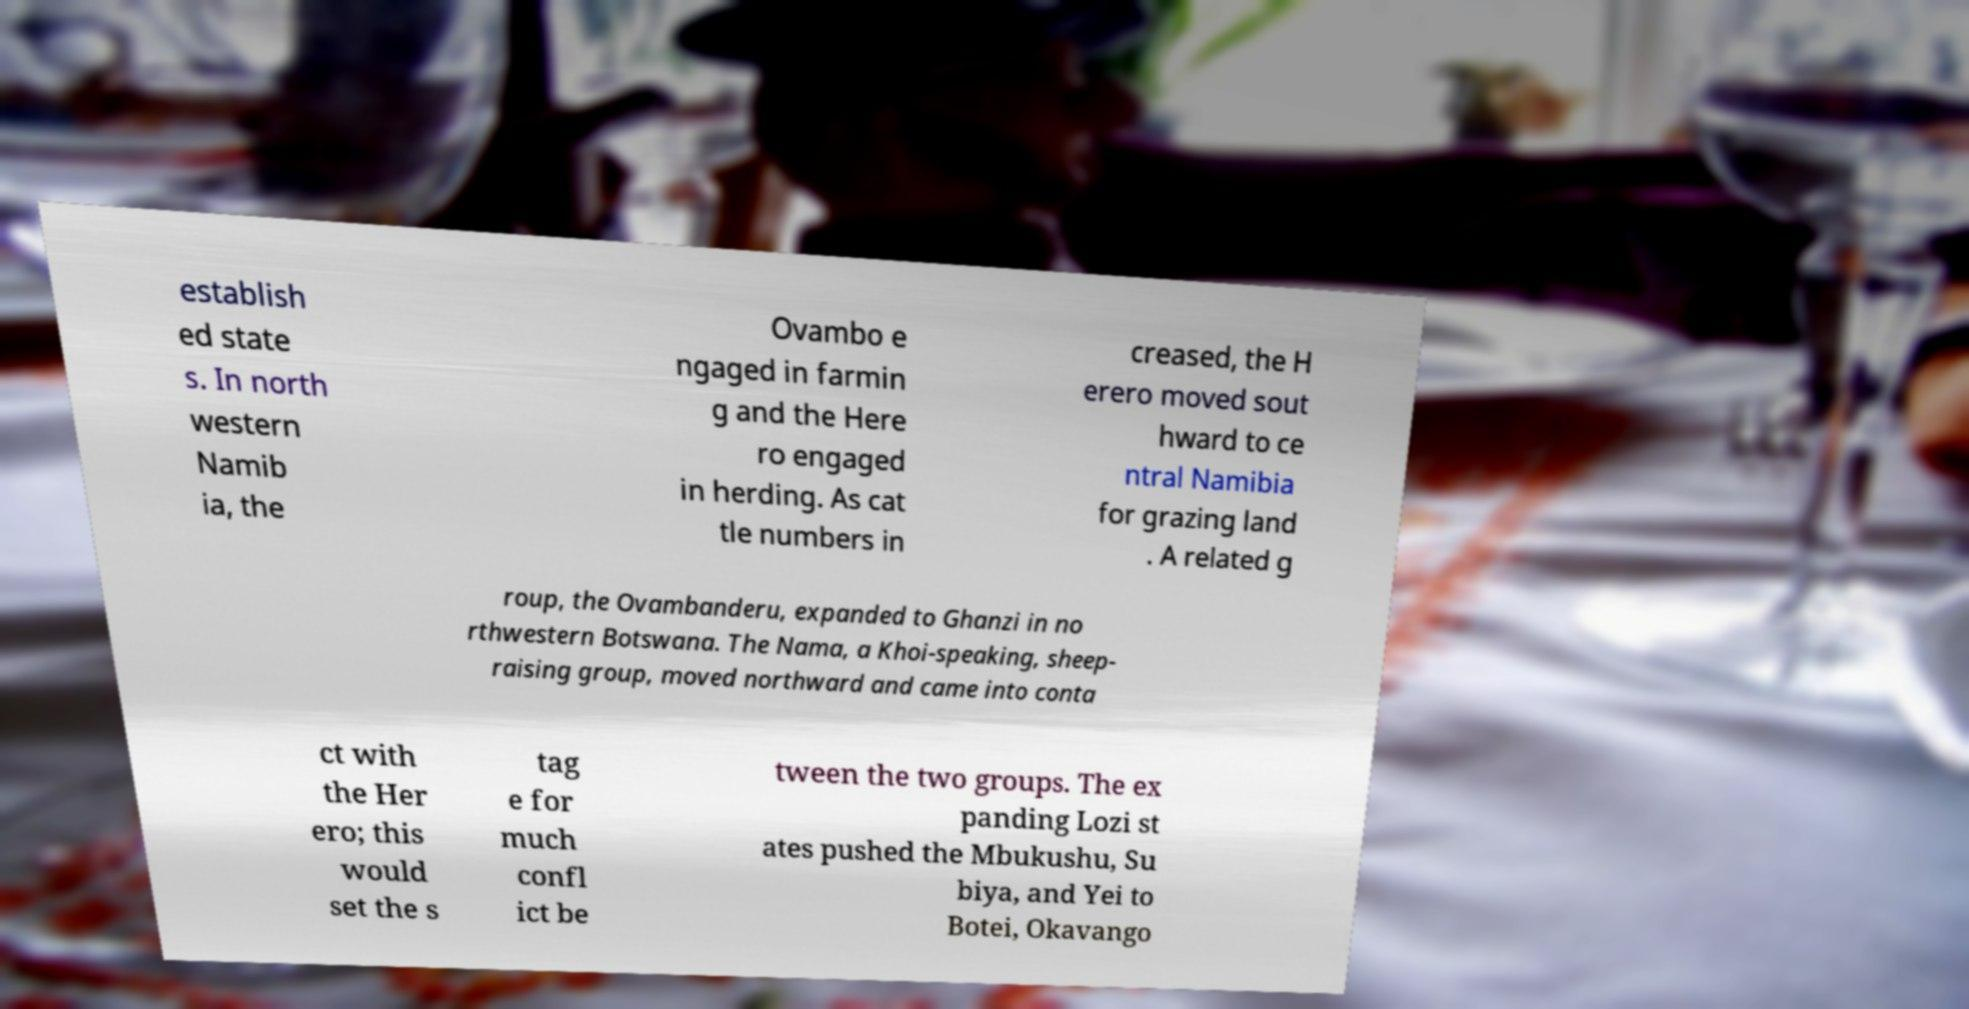There's text embedded in this image that I need extracted. Can you transcribe it verbatim? establish ed state s. In north western Namib ia, the Ovambo e ngaged in farmin g and the Here ro engaged in herding. As cat tle numbers in creased, the H erero moved sout hward to ce ntral Namibia for grazing land . A related g roup, the Ovambanderu, expanded to Ghanzi in no rthwestern Botswana. The Nama, a Khoi-speaking, sheep- raising group, moved northward and came into conta ct with the Her ero; this would set the s tag e for much confl ict be tween the two groups. The ex panding Lozi st ates pushed the Mbukushu, Su biya, and Yei to Botei, Okavango 